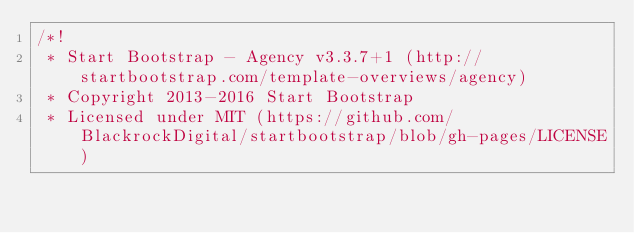<code> <loc_0><loc_0><loc_500><loc_500><_CSS_>/*!
 * Start Bootstrap - Agency v3.3.7+1 (http://startbootstrap.com/template-overviews/agency)
 * Copyright 2013-2016 Start Bootstrap
 * Licensed under MIT (https://github.com/BlackrockDigital/startbootstrap/blob/gh-pages/LICENSE)</code> 